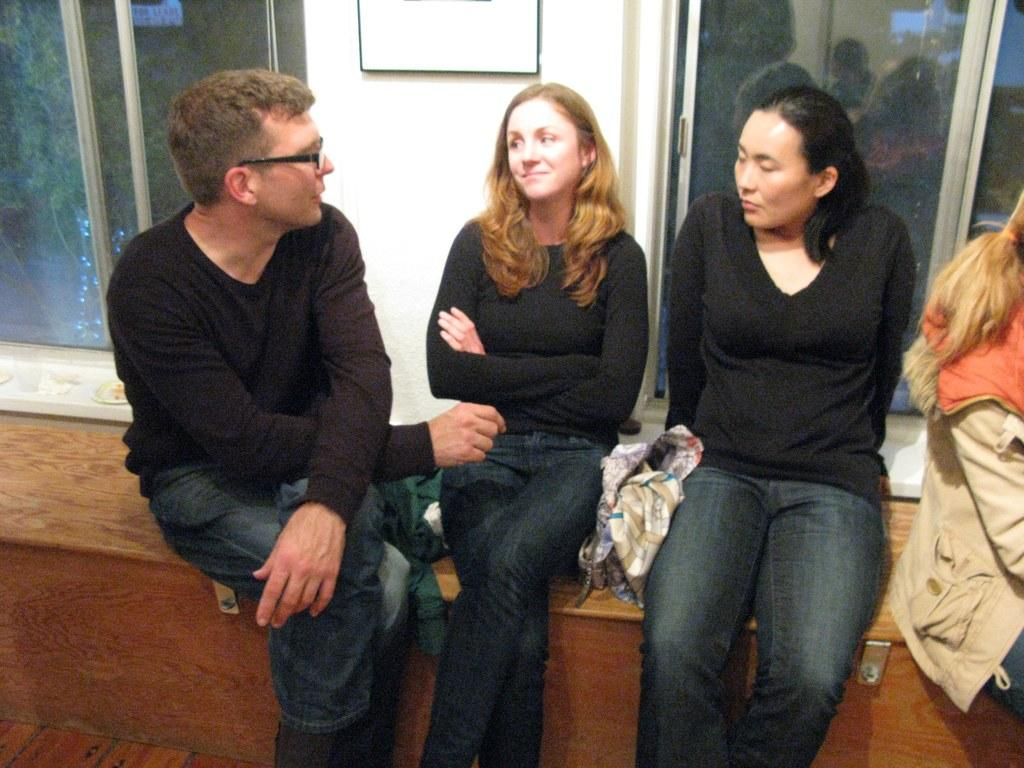How many people are sitting on the bench in the image? There are four persons sitting on a bench in the image. Can you describe the appearance of one of the persons? One person is wearing a black t-shirt and spectacles. What can be seen in the background of the image? There are windows visible in the background of the image. What is present on the wall in the background of the image? There is a photo frame on the wall in the background of the image. What type of scent can be smelled coming from the flower in the image? There is no flower present in the image, so it is not possible to determine the scent. 